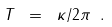<formula> <loc_0><loc_0><loc_500><loc_500>T \ = \ \kappa / 2 \pi \ .</formula> 